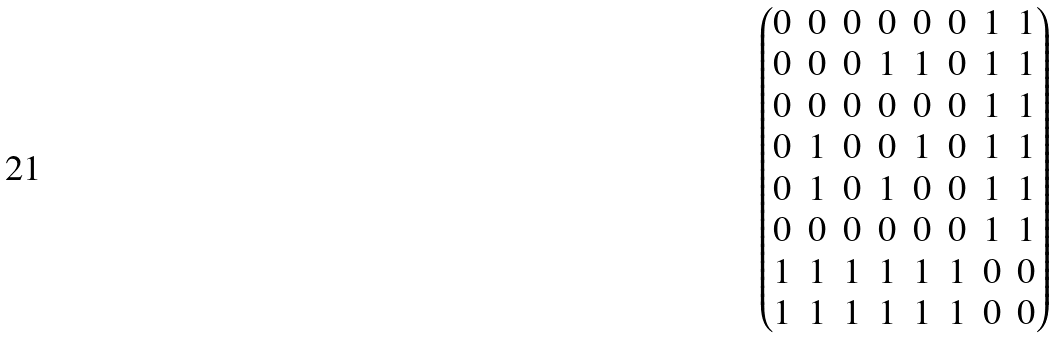Convert formula to latex. <formula><loc_0><loc_0><loc_500><loc_500>\begin{pmatrix} 0 & 0 & 0 & 0 & 0 & 0 & 1 & 1 \\ 0 & 0 & 0 & 1 & 1 & 0 & 1 & 1 \\ 0 & 0 & 0 & 0 & 0 & 0 & 1 & 1 \\ 0 & 1 & 0 & 0 & 1 & 0 & 1 & 1 \\ 0 & 1 & 0 & 1 & 0 & 0 & 1 & 1 \\ 0 & 0 & 0 & 0 & 0 & 0 & 1 & 1 \\ 1 & 1 & 1 & 1 & 1 & 1 & 0 & 0 \\ 1 & 1 & 1 & 1 & 1 & 1 & 0 & 0 \end{pmatrix}</formula> 